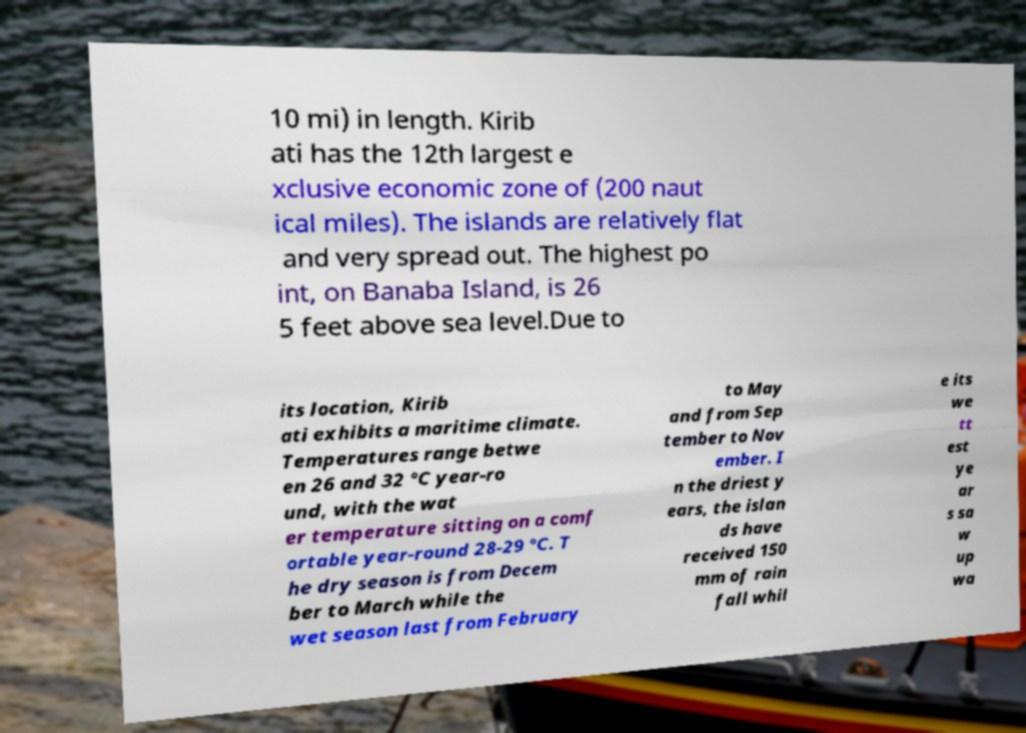Please read and relay the text visible in this image. What does it say? 10 mi) in length. Kirib ati has the 12th largest e xclusive economic zone of (200 naut ical miles). The islands are relatively flat and very spread out. The highest po int, on Banaba Island, is 26 5 feet above sea level.Due to its location, Kirib ati exhibits a maritime climate. Temperatures range betwe en 26 and 32 °C year-ro und, with the wat er temperature sitting on a comf ortable year-round 28-29 °C. T he dry season is from Decem ber to March while the wet season last from February to May and from Sep tember to Nov ember. I n the driest y ears, the islan ds have received 150 mm of rain fall whil e its we tt est ye ar s sa w up wa 